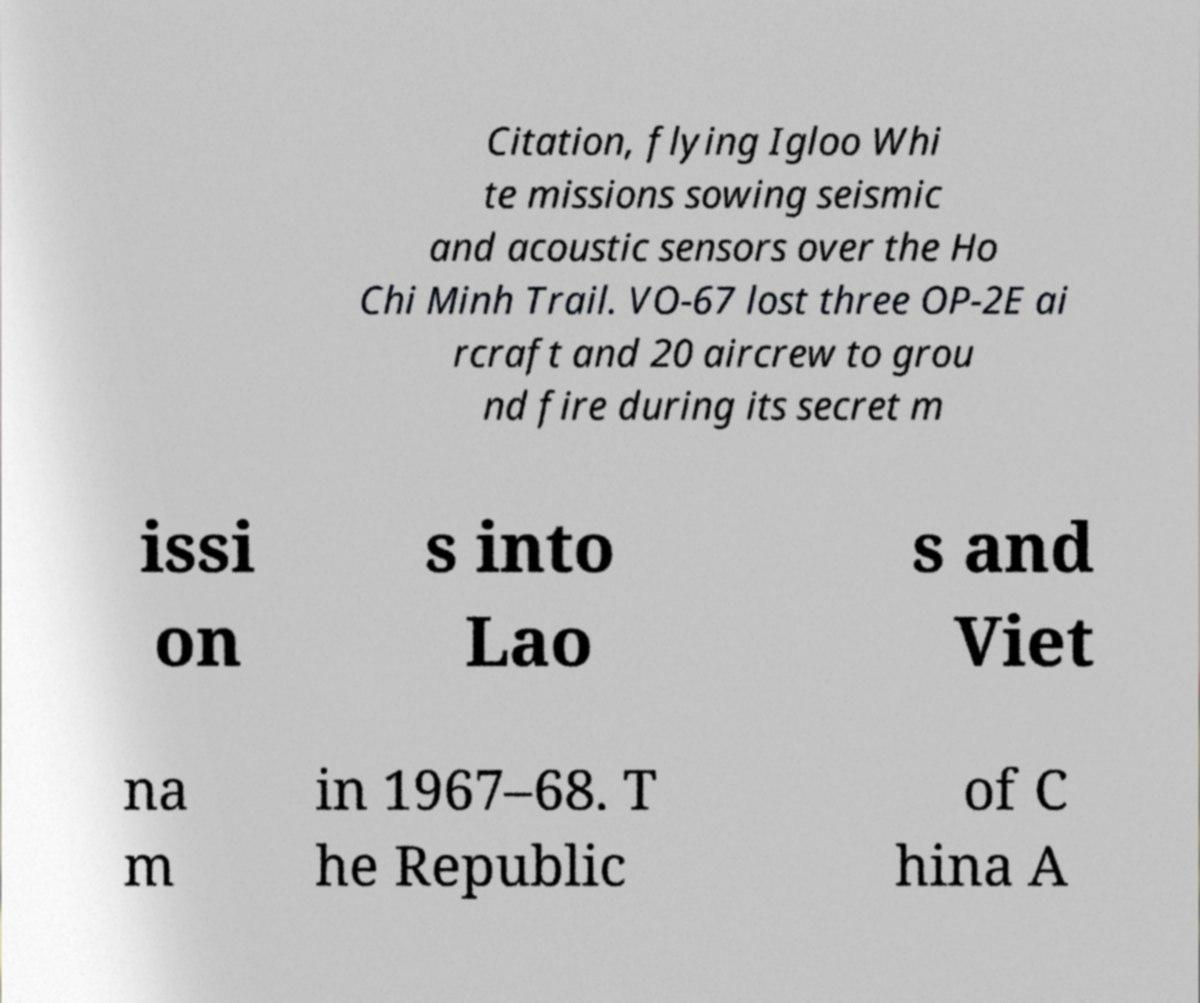Could you assist in decoding the text presented in this image and type it out clearly? Citation, flying Igloo Whi te missions sowing seismic and acoustic sensors over the Ho Chi Minh Trail. VO-67 lost three OP-2E ai rcraft and 20 aircrew to grou nd fire during its secret m issi on s into Lao s and Viet na m in 1967–68. T he Republic of C hina A 